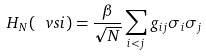Convert formula to latex. <formula><loc_0><loc_0><loc_500><loc_500>H _ { N } ( \ v s i ) = \frac { \beta } { \sqrt { N } } \sum _ { i < j } g _ { i j } \sigma _ { i } \sigma _ { j }</formula> 